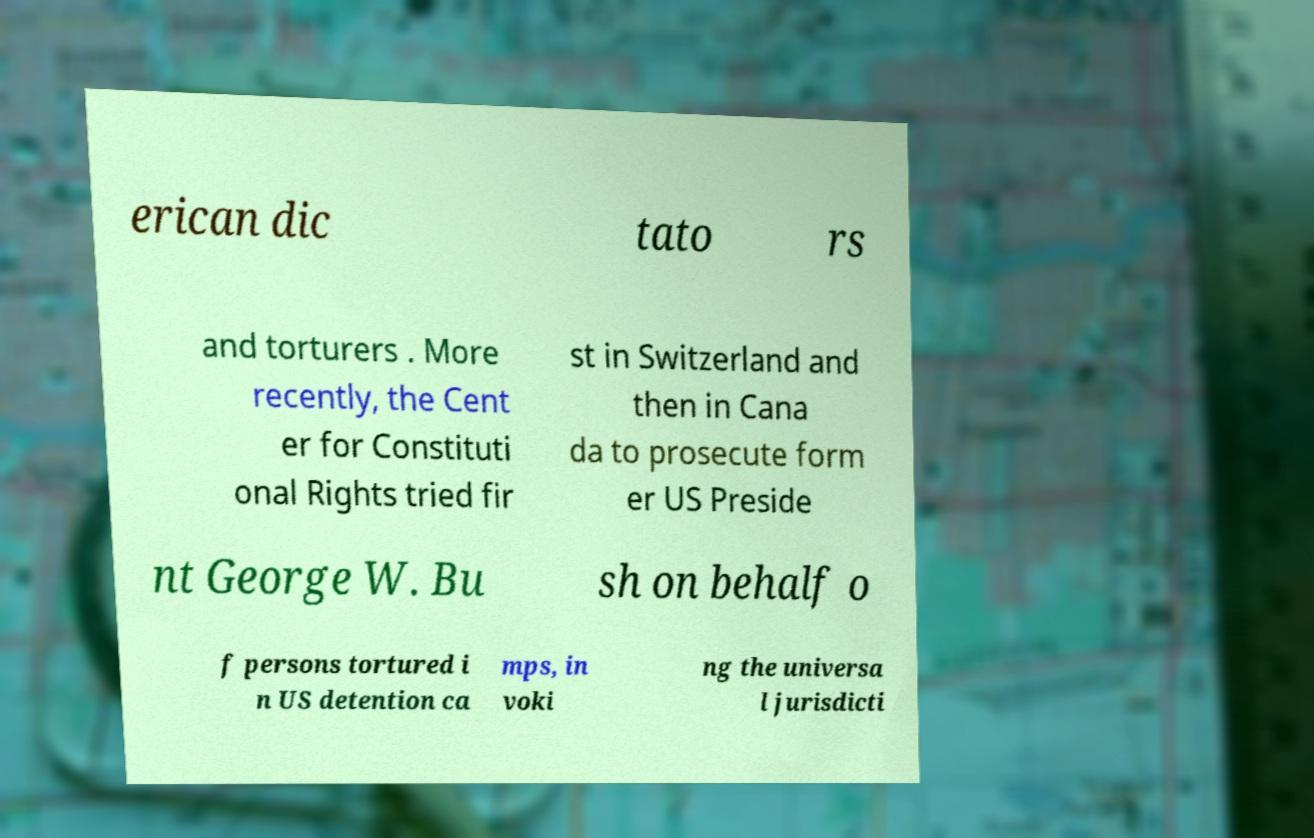Can you accurately transcribe the text from the provided image for me? erican dic tato rs and torturers . More recently, the Cent er for Constituti onal Rights tried fir st in Switzerland and then in Cana da to prosecute form er US Preside nt George W. Bu sh on behalf o f persons tortured i n US detention ca mps, in voki ng the universa l jurisdicti 